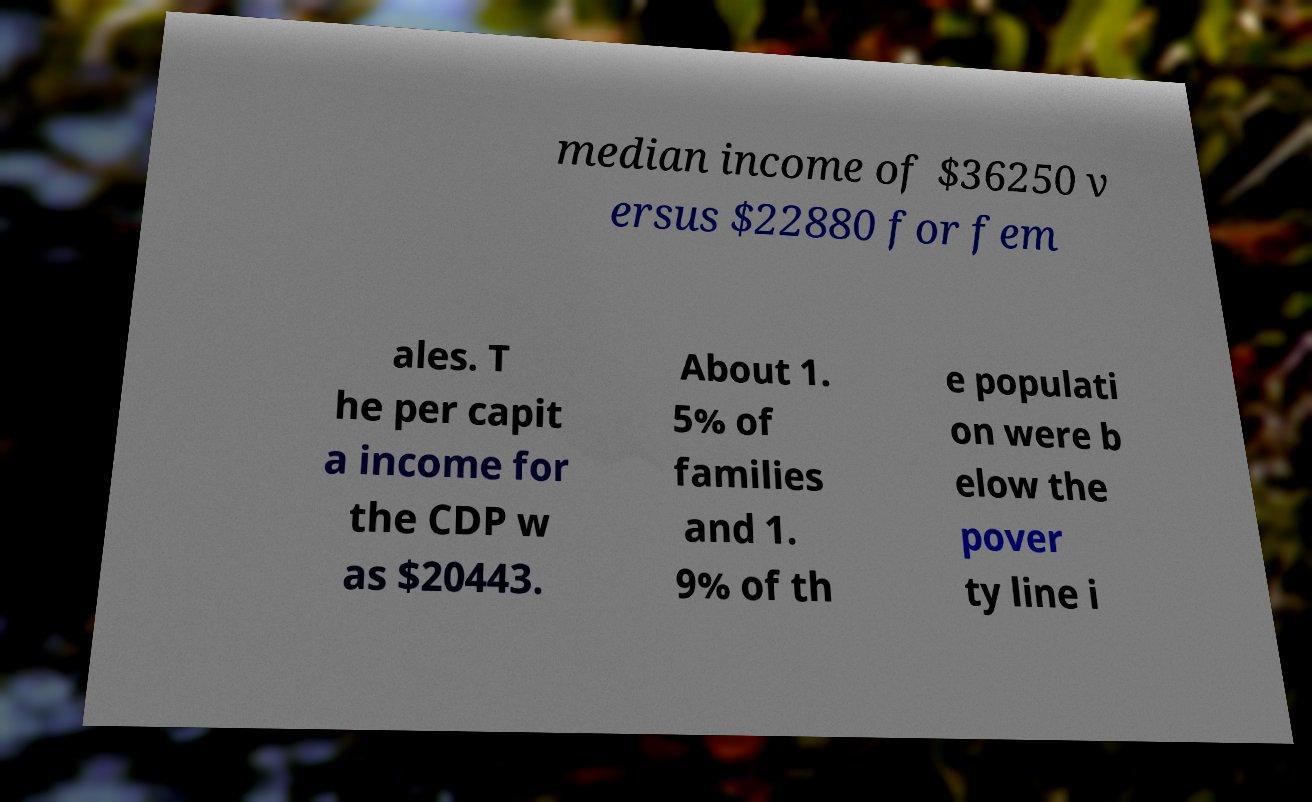Can you accurately transcribe the text from the provided image for me? median income of $36250 v ersus $22880 for fem ales. T he per capit a income for the CDP w as $20443. About 1. 5% of families and 1. 9% of th e populati on were b elow the pover ty line i 